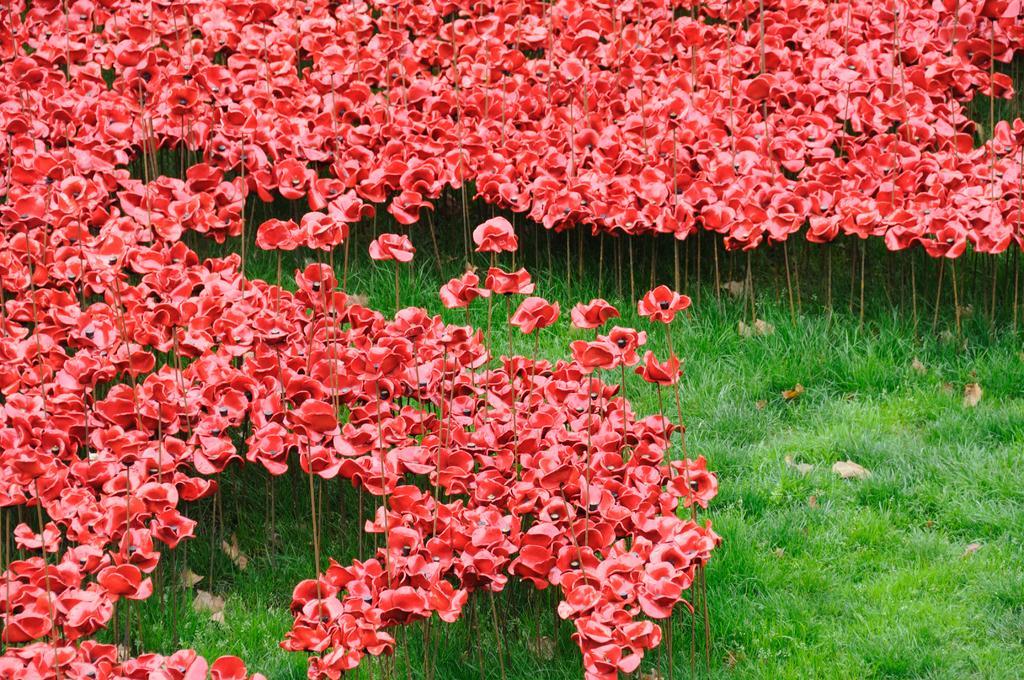How would you summarize this image in a sentence or two? At the bottom of this image, there are plants having flowers and there's grass on the ground. In the background, there are plants having flowers and there's grass on the ground. 